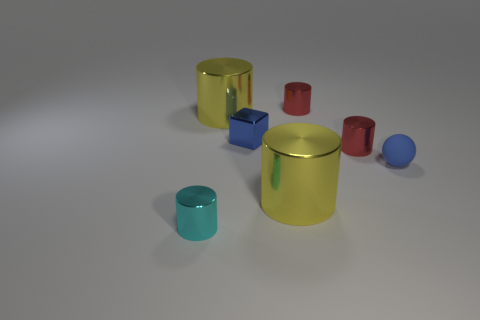Subtract all green cylinders. Subtract all brown spheres. How many cylinders are left? 5 Add 3 small blue balls. How many objects exist? 10 Subtract all spheres. How many objects are left? 6 Add 1 matte balls. How many matte balls exist? 2 Subtract 0 gray cylinders. How many objects are left? 7 Subtract all red metallic things. Subtract all tiny cylinders. How many objects are left? 2 Add 7 tiny red things. How many tiny red things are left? 9 